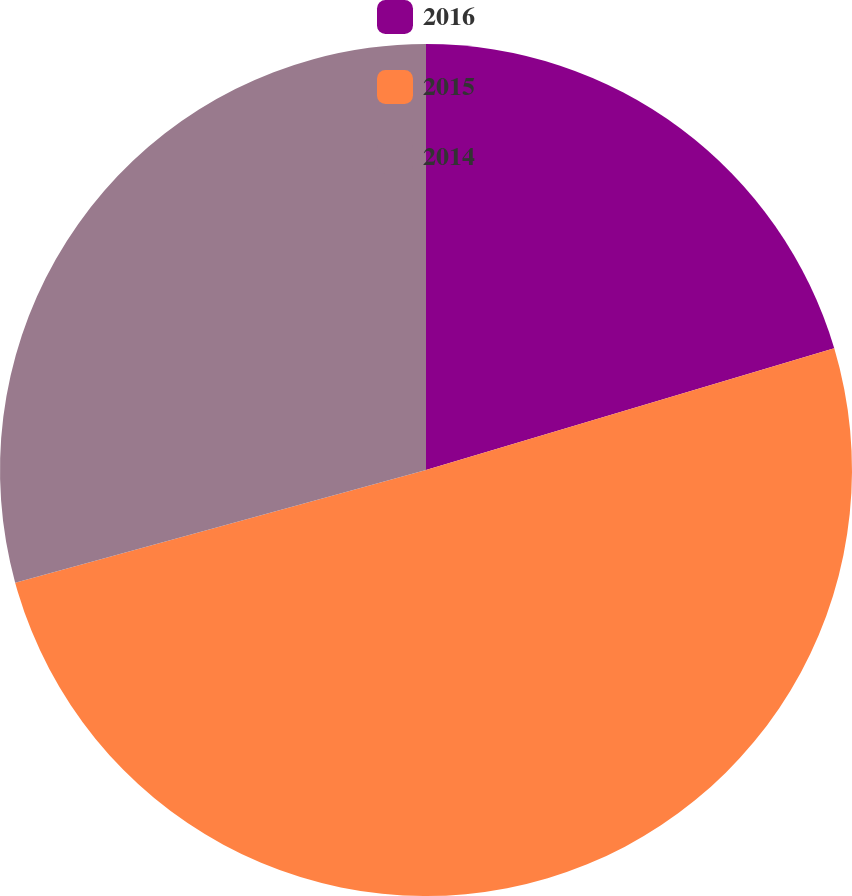Convert chart to OTSL. <chart><loc_0><loc_0><loc_500><loc_500><pie_chart><fcel>2016<fcel>2015<fcel>2014<nl><fcel>20.39%<fcel>50.35%<fcel>29.26%<nl></chart> 